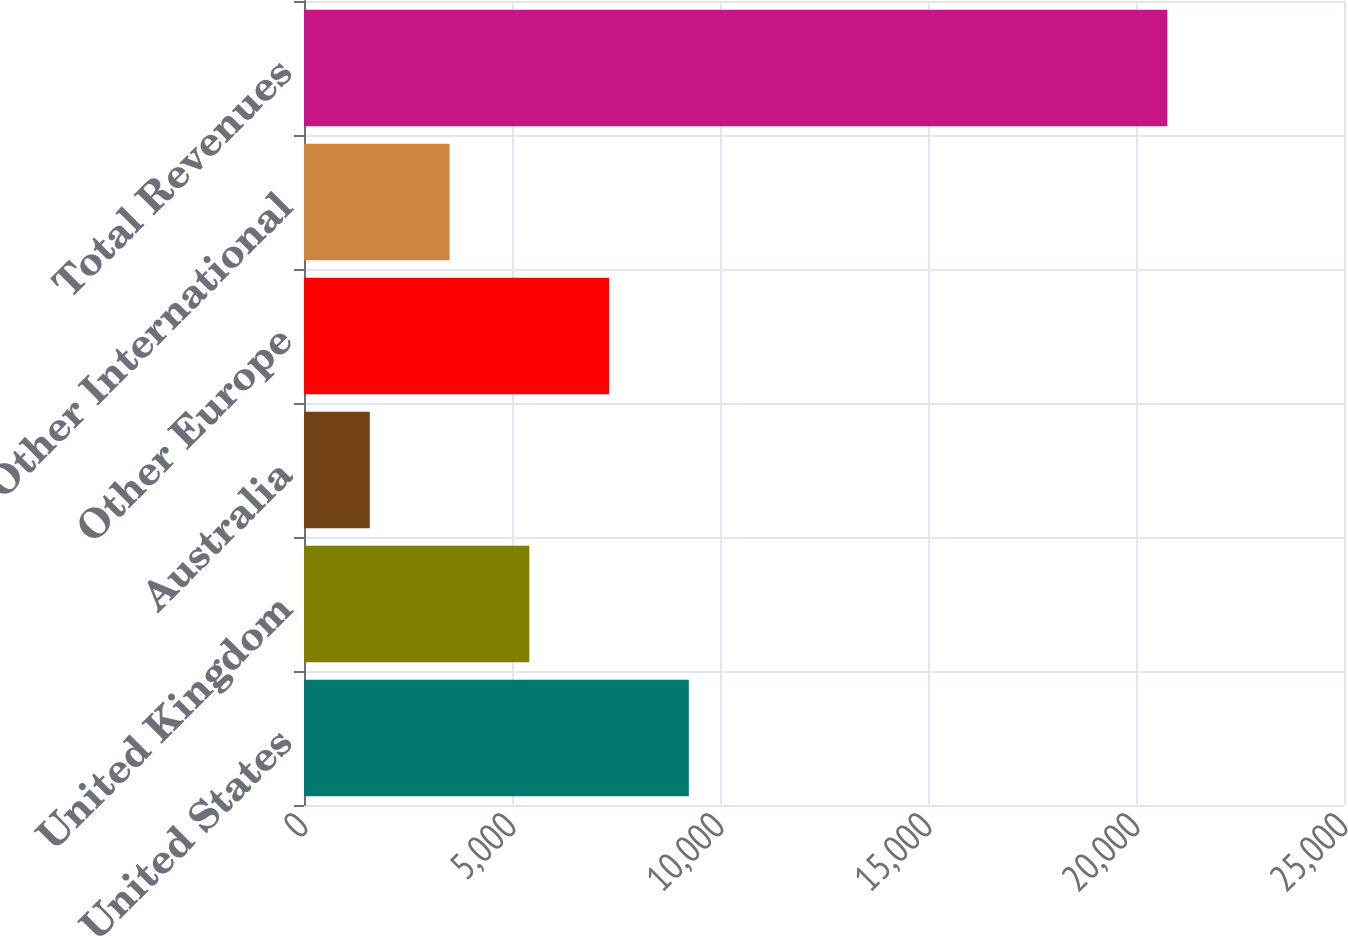<chart> <loc_0><loc_0><loc_500><loc_500><bar_chart><fcel>United States<fcel>United Kingdom<fcel>Australia<fcel>Other Europe<fcel>Other International<fcel>Total Revenues<nl><fcel>9250.4<fcel>5416.2<fcel>1582<fcel>7333.3<fcel>3499.1<fcel>20753<nl></chart> 